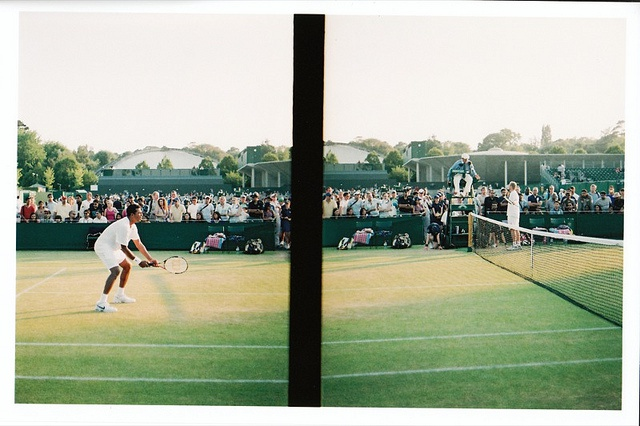Describe the objects in this image and their specific colors. I can see people in lightgray, black, gray, and darkgray tones, people in lightgray, black, maroon, and tan tones, people in lightgray, darkgray, and gray tones, tennis racket in lightgray, tan, beige, gray, and darkgray tones, and people in lightgray, black, gray, maroon, and darkgray tones in this image. 